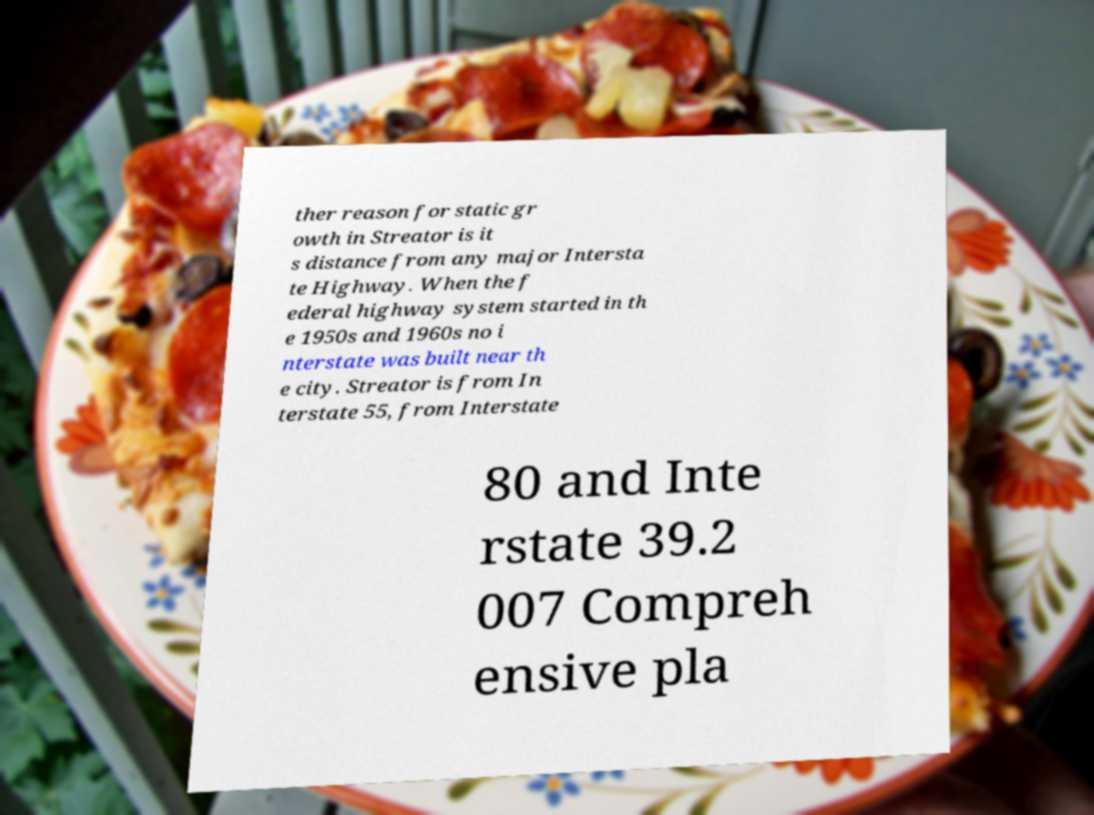Could you extract and type out the text from this image? ther reason for static gr owth in Streator is it s distance from any major Intersta te Highway. When the f ederal highway system started in th e 1950s and 1960s no i nterstate was built near th e city. Streator is from In terstate 55, from Interstate 80 and Inte rstate 39.2 007 Compreh ensive pla 